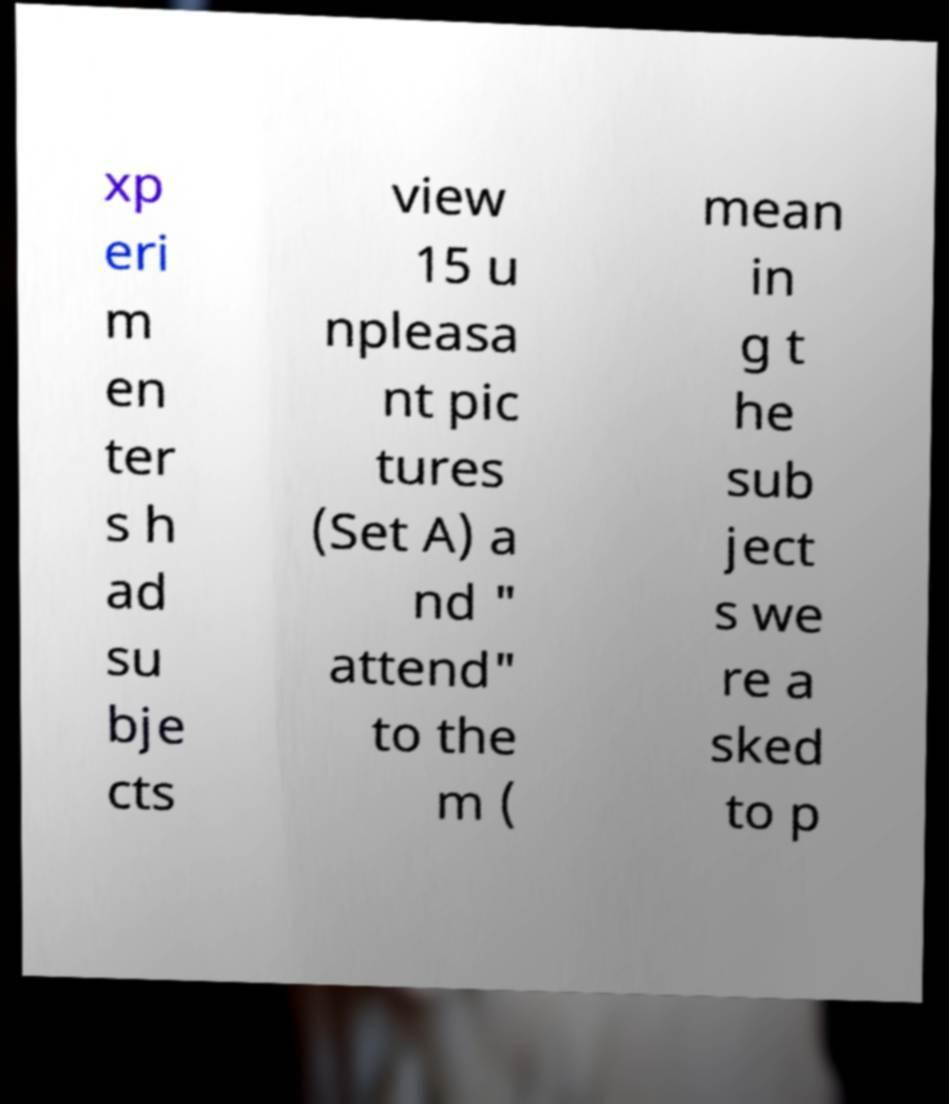There's text embedded in this image that I need extracted. Can you transcribe it verbatim? xp eri m en ter s h ad su bje cts view 15 u npleasa nt pic tures (Set A) a nd " attend" to the m ( mean in g t he sub ject s we re a sked to p 